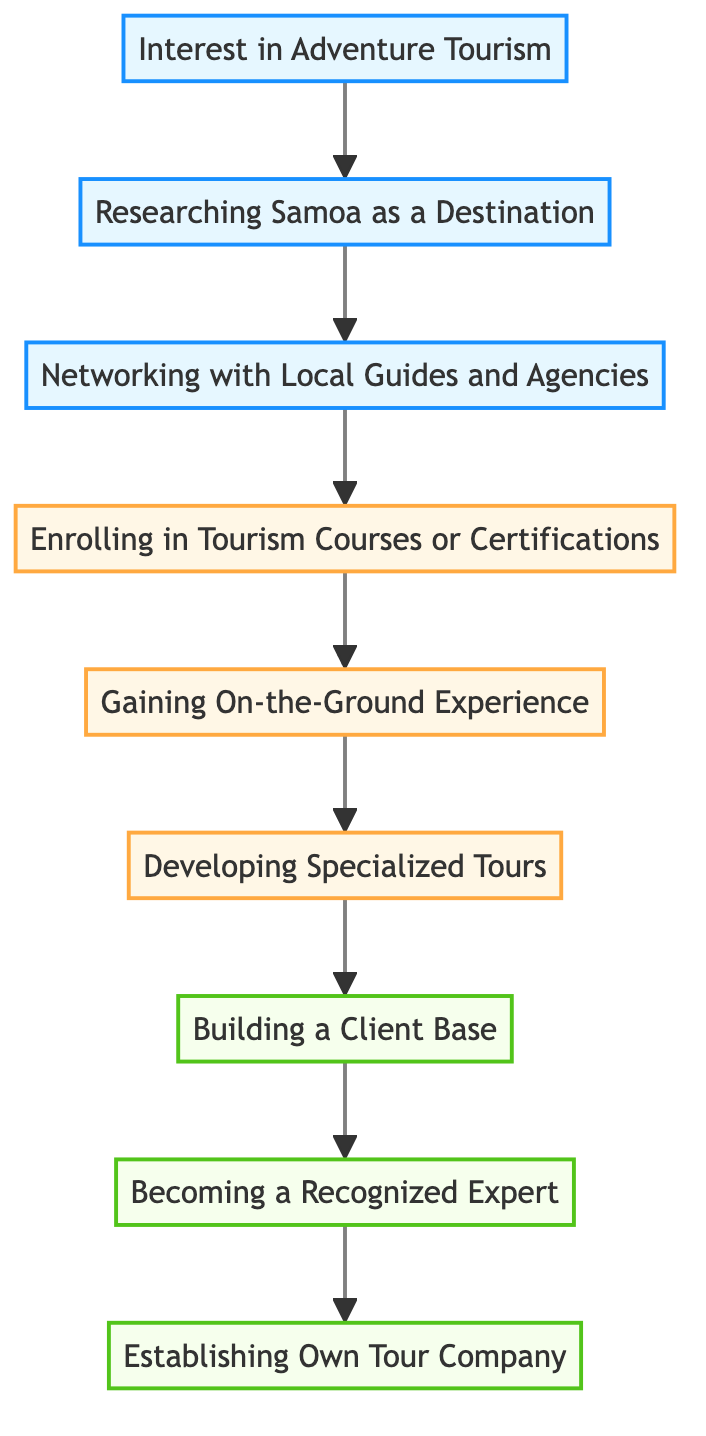What is the first step in the career path? The diagram indicates that the first step is "Interest in Adventure Tourism" as it is the starting point of the flow chart.
Answer: Interest in Adventure Tourism How many total steps are there in the diagram? By counting the nodes in the diagram, there are 9 distinct steps representing each level in the career path.
Answer: 9 What is the title of level 6? The title for level 6 is "Developing Specialized Tours," which is explicitly stated as part of that level in the diagram.
Answer: Developing Specialized Tours Which step immediately follows "Gaining On-the-Ground Experience"? The diagram shows that "Developing Specialized Tours" comes immediately after "Gaining On-the-Ground Experience."
Answer: Developing Specialized Tours What is the relationship between "Researching Samoa as a Destination" and "Networking with Local Guides and Agencies"? The relationship is sequential; "Researching Samoa as a Destination" leads to "Networking with Local Guides and Agencies," indicating that research is a prerequisite for networking.
Answer: Sequential Which level focuses on establishing credibility? The diagram identifies "Becoming a Recognized Expert" as the level focusing on establishing credibility within the career path.
Answer: Becoming a Recognized Expert What does level 9 represent? Level 9 represents "Establishing Own Tour Company," indicating the culmination of the career path in the diagram.
Answer: Establishing Own Tour Company How does one build a client base according to the diagram? According to the diagram, one can build a client base by leveraging social media and partnerships to attract tourists.
Answer: Leveraging social media and partnerships What is a unique activity mentioned in level 6? The unique activity mentioned in level 6 is "hiking trips to Mount Vaea" which is one of the specialized tours developed in this step.
Answer: Hiking trips to Mount Vaea 